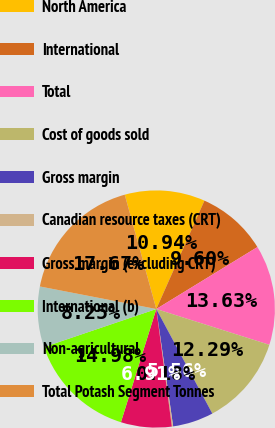<chart> <loc_0><loc_0><loc_500><loc_500><pie_chart><fcel>North America<fcel>International<fcel>Total<fcel>Cost of goods sold<fcel>Gross margin<fcel>Canadian resource taxes (CRT)<fcel>Gross margin (excluding CRT)<fcel>International (b)<fcel>Non-agricultural<fcel>Total Potash Segment Tonnes<nl><fcel>10.94%<fcel>9.6%<fcel>13.63%<fcel>12.29%<fcel>5.56%<fcel>0.18%<fcel>6.91%<fcel>14.98%<fcel>8.25%<fcel>17.67%<nl></chart> 